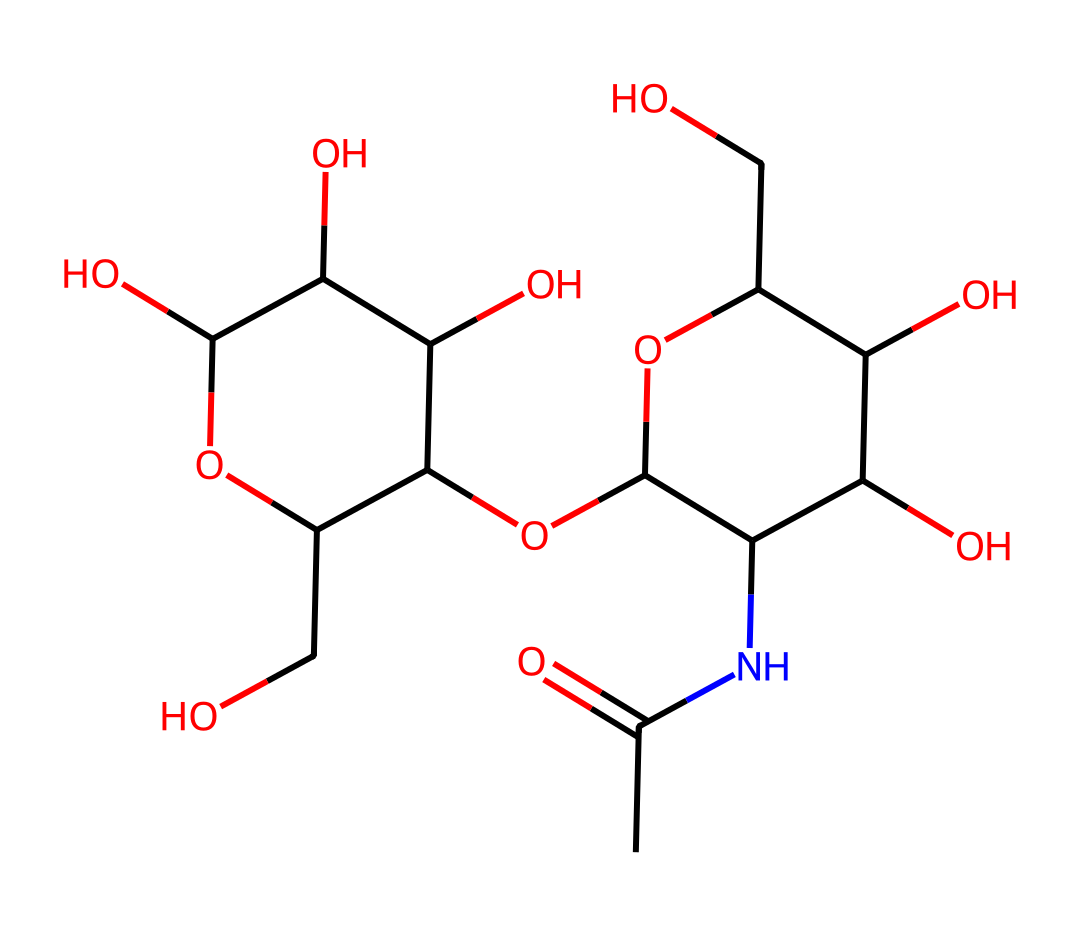What is the primary functional group present in this molecule? The molecule contains an amide group, indicated by the nitrogen atom bonded to a carbonyl (C=O) next to a carbon chain. This structural feature is characteristic of amides.
Answer: amide How many hydroxyl groups are present in this chemical? By analyzing the chemical's structure, we can identify four hydroxyl (-OH) groups as indicated by their presence on various carbon atoms in the structure.
Answer: four What is the total number of carbon atoms in this molecule? Counting all the carbon atoms present in the structure leads to a total of thirteen carbon atoms indicated by the framework of the chemical.
Answer: thirteen Does this chemical exhibit properties consistent with hydrophilicity? The presence of multiple hydroxyl groups and the amide group suggests that this chemical is hydrophilic, as these functional groups are known to increase water solubility.
Answer: yes What role does hyaluronic acid play in skin moisturizers? The chemical structure's ability to interact with water allows hyaluronic acid to retain moisture in the skin, acting as a humectant.
Answer: humectant In what state is this chemical expected to be at room temperature? Given its structure and the functional groups involved, this chemical is likely to be in a viscous liquid state at room temperature due to its hydrophilic nature.
Answer: viscous liquid 